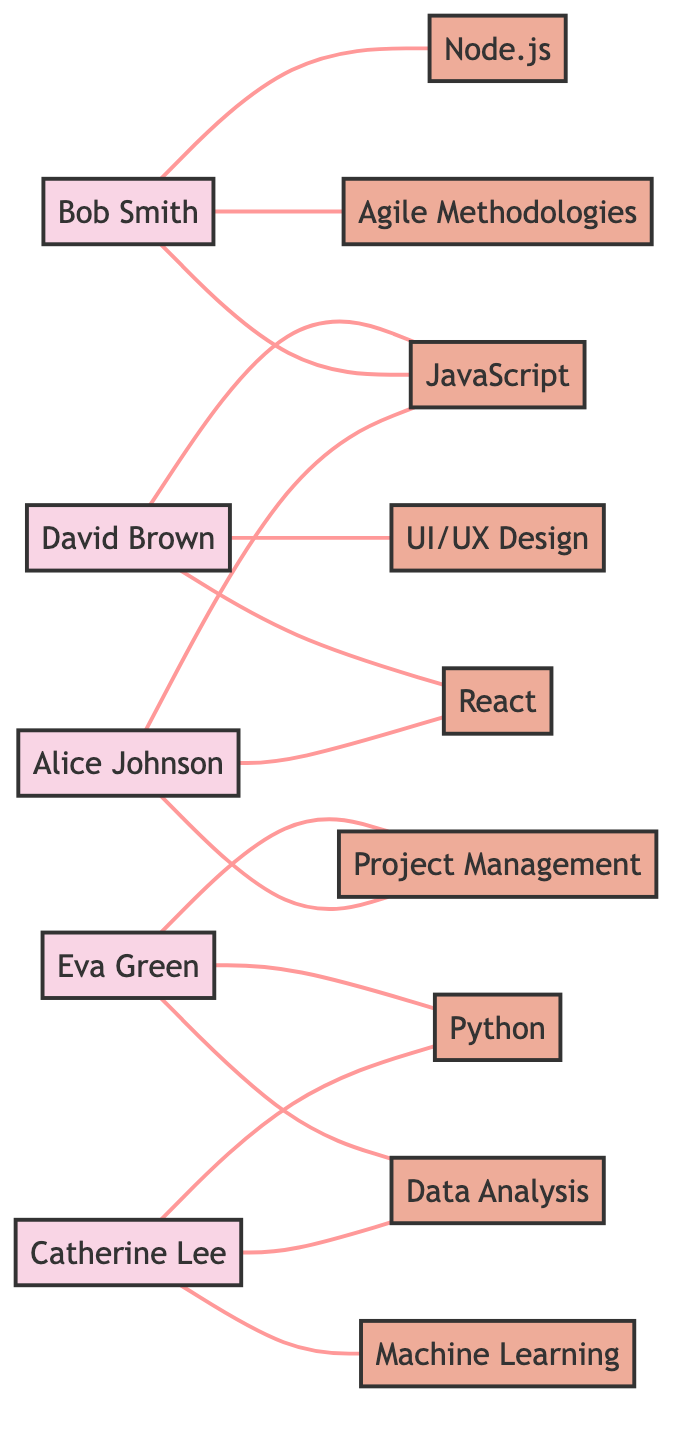What skills does Alice Johnson possess? From the diagram, Alice Johnson is connected to the skills nodes of JavaScript, React, and Project Management. These skills are the ones directly linked to her in the graph.
Answer: JavaScript, React, Project Management How many employees have the skill "Python"? The Python skill node connects to two employees: Catherine Lee and Eva Green. By counting the connections to the Python skill node, we find that two employees are linked to it.
Answer: 2 Which employee has the unique skill "Node.js"? The skill node for Node.js is connected only to Bob Smith. As there are no other connections to the Node.js node, we can determine that Bob Smith is the sole employee with this skill.
Answer: Bob Smith What is the total number of skills represented in the diagram? By counting all the skill nodes present in the diagram, we find that there are nine unique skills illustrated. Hence, the total number of skills is nine.
Answer: 9 Which two employees are connected through the "Data Analysis" skill? The Data Analysis skill node connects to Catherine Lee and Eva Green. By tracing the connections from the Data Analysis skill node, we can identify these two employees.
Answer: Catherine Lee, Eva Green Which employee has the most skills attributed to them? Alice Johnson has three skills connected to her node: JavaScript, React, and Project Management. By comparing all employees' skills, Alice Johnson has the highest count.
Answer: Alice Johnson How many employees possess the skill "Agile Methodologies"? The Agile Methodologies skill node is directly connected to only one employee, which is Bob Smith. By checking the connection line from the Agile Methodologies node, we confirm this.
Answer: 1 Are there any skills that only one employee has? Yes, both Node.js and UI/UX Design skills are only connected to one employee each (Node.js to Bob Smith and UI/UX Design to David Brown). Thus, both skills are unique to a single employee.
Answer: Node.js, UI/UX Design 